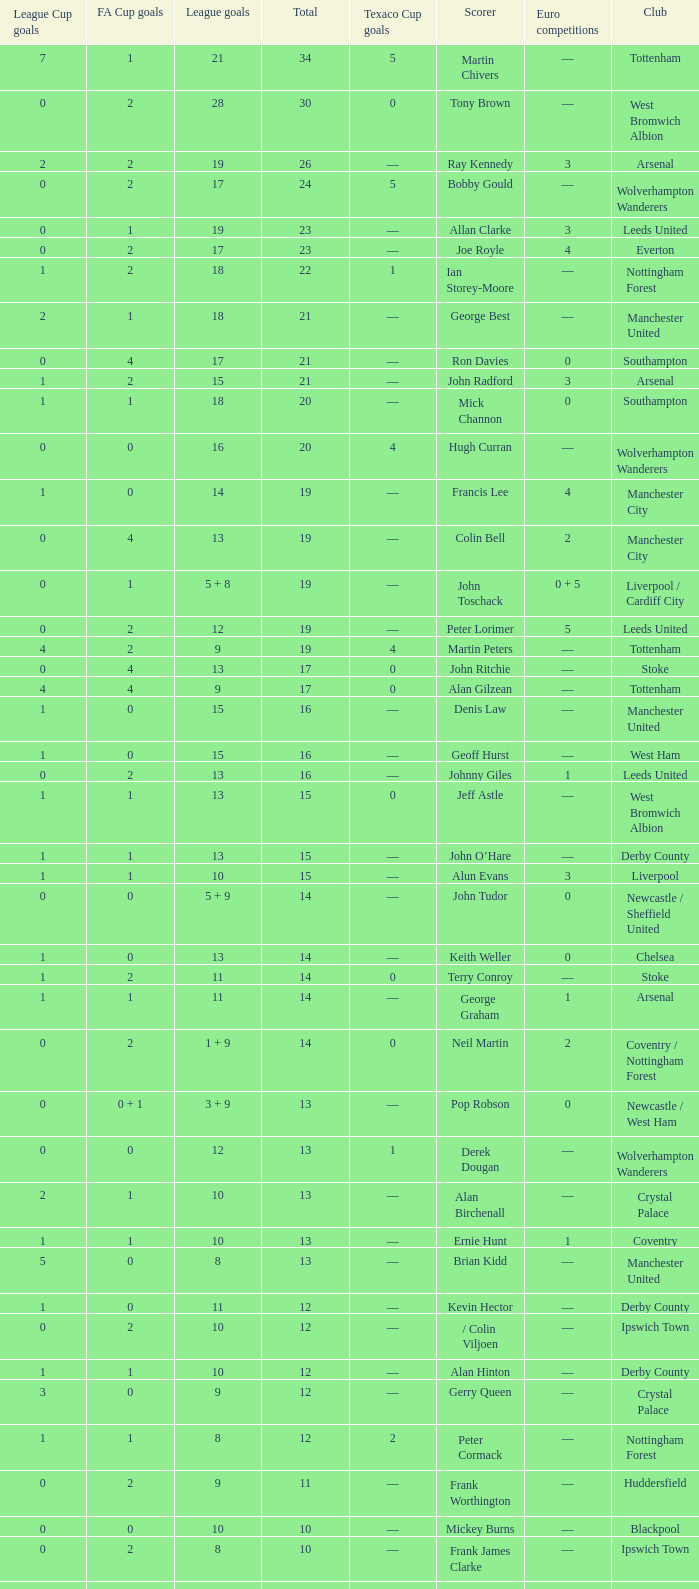What is the average Total, when FA Cup Goals is 1, when League Goals is 10, and when Club is Crystal Palace? 13.0. 